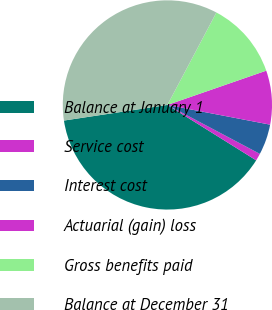Convert chart to OTSL. <chart><loc_0><loc_0><loc_500><loc_500><pie_chart><fcel>Balance at January 1<fcel>Service cost<fcel>Interest cost<fcel>Actuarial (gain) loss<fcel>Gross benefits paid<fcel>Balance at December 31<nl><fcel>38.74%<fcel>1.13%<fcel>4.73%<fcel>8.33%<fcel>11.93%<fcel>35.14%<nl></chart> 